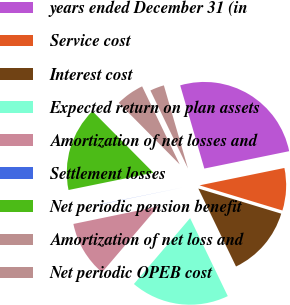Convert chart to OTSL. <chart><loc_0><loc_0><loc_500><loc_500><pie_chart><fcel>years ended December 31 (in<fcel>Service cost<fcel>Interest cost<fcel>Expected return on plan assets<fcel>Amortization of net losses and<fcel>Settlement losses<fcel>Net periodic pension benefit<fcel>Amortization of net loss and<fcel>Net periodic OPEB cost<nl><fcel>26.28%<fcel>7.9%<fcel>13.15%<fcel>18.4%<fcel>10.53%<fcel>0.03%<fcel>15.78%<fcel>5.28%<fcel>2.65%<nl></chart> 